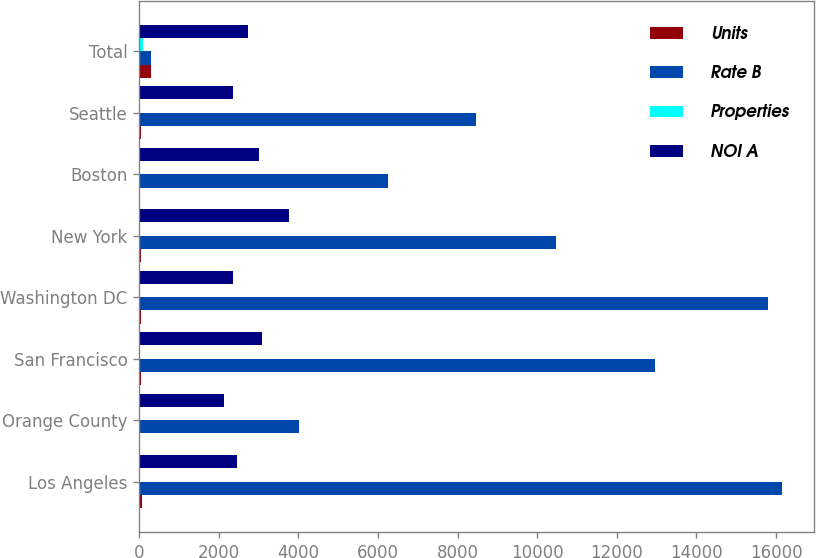Convert chart. <chart><loc_0><loc_0><loc_500><loc_500><stacked_bar_chart><ecel><fcel>Los Angeles<fcel>Orange County<fcel>San Francisco<fcel>Washington DC<fcel>New York<fcel>Boston<fcel>Seattle<fcel>Total<nl><fcel>Units<fcel>71<fcel>13<fcel>54<fcel>48<fcel>39<fcel>24<fcel>41<fcel>303<nl><fcel>Rate B<fcel>16160<fcel>4028<fcel>12961<fcel>15811<fcel>10462<fcel>6263<fcel>8460<fcel>303<nl><fcel>Properties<fcel>18.6<fcel>4.4<fcel>19.5<fcel>17.3<fcel>16.5<fcel>9.9<fcel>9.9<fcel>100<nl><fcel>NOI A<fcel>2454<fcel>2142<fcel>3089<fcel>2360<fcel>3758<fcel>3001<fcel>2365<fcel>2729<nl></chart> 